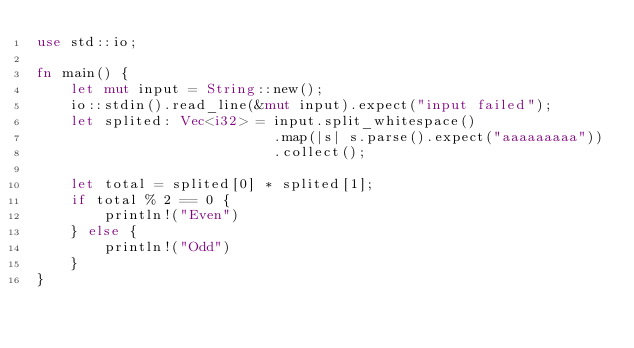Convert code to text. <code><loc_0><loc_0><loc_500><loc_500><_Rust_>use std::io;

fn main() {
    let mut input = String::new();
    io::stdin().read_line(&mut input).expect("input failed");
    let splited: Vec<i32> = input.split_whitespace()
                            .map(|s| s.parse().expect("aaaaaaaaa"))
                            .collect();

    let total = splited[0] * splited[1];
    if total % 2 == 0 {
        println!("Even")
    } else {
        println!("Odd")
    }
}
</code> 